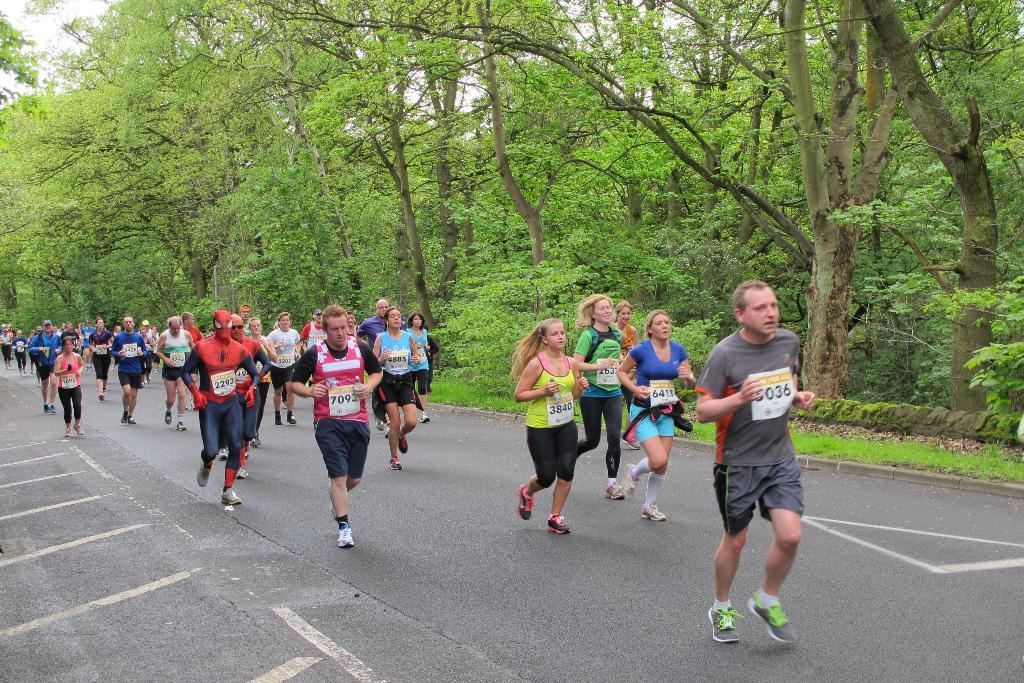What are the people in the image doing? The people in the image are running on the road. What can be seen in the background of the image? Trees and grass are visible in the image. What type of watch is the person wearing while running in the image? There is no watch visible on any of the people running in the image. 